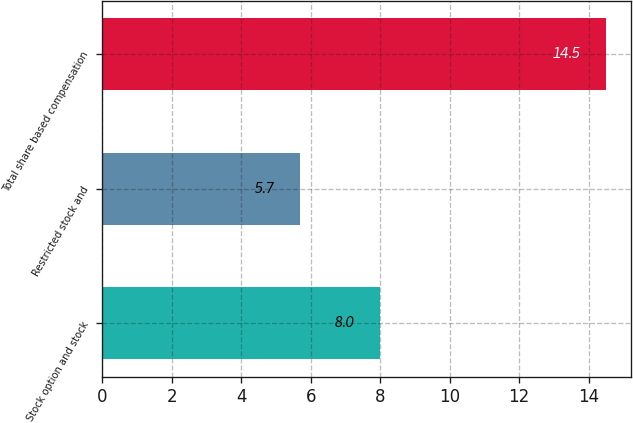Convert chart to OTSL. <chart><loc_0><loc_0><loc_500><loc_500><bar_chart><fcel>Stock option and stock<fcel>Restricted stock and<fcel>Total share based compensation<nl><fcel>8<fcel>5.7<fcel>14.5<nl></chart> 